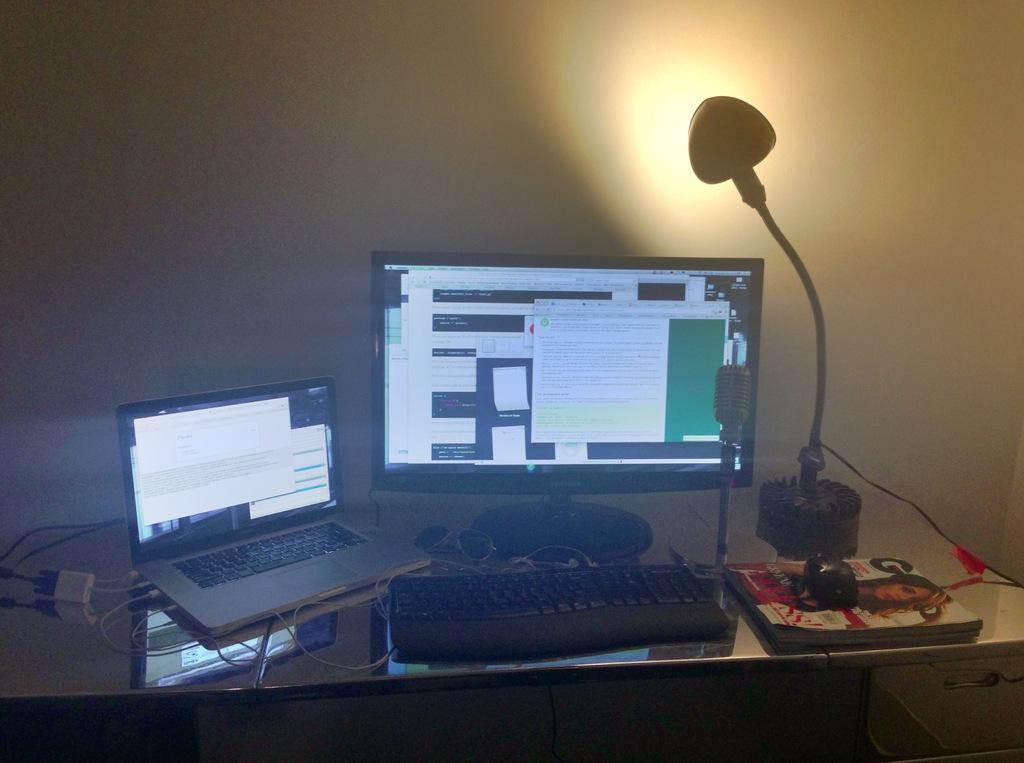<image>
Write a terse but informative summary of the picture. A desktop and a laptop next to a GQ magazine. 